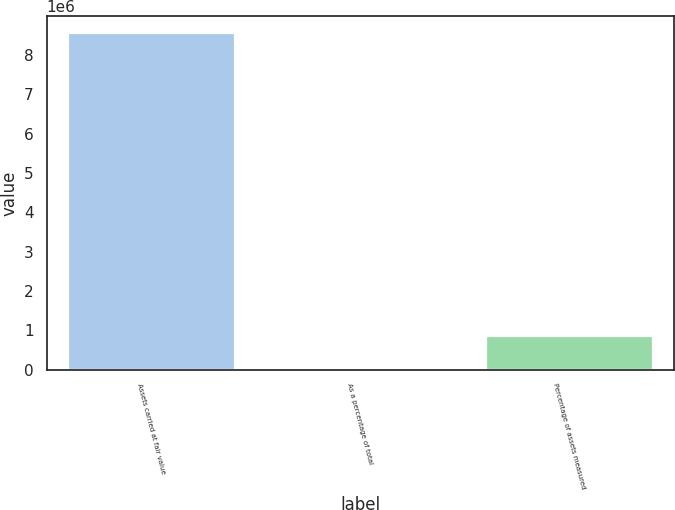Convert chart. <chart><loc_0><loc_0><loc_500><loc_500><bar_chart><fcel>Assets carried at fair value<fcel>As a percentage of total<fcel>Percentage of assets measured<nl><fcel>8.54653e+06<fcel>48.8<fcel>854697<nl></chart> 